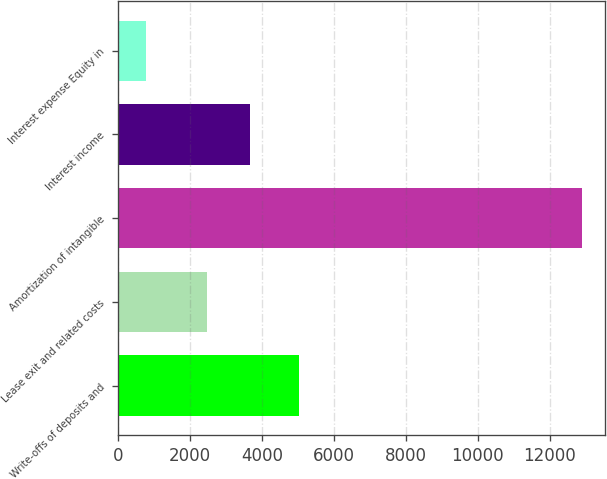<chart> <loc_0><loc_0><loc_500><loc_500><bar_chart><fcel>Write-offs of deposits and<fcel>Lease exit and related costs<fcel>Amortization of intangible<fcel>Interest income<fcel>Interest expense Equity in<nl><fcel>5021<fcel>2463<fcel>12900<fcel>3674.2<fcel>788<nl></chart> 